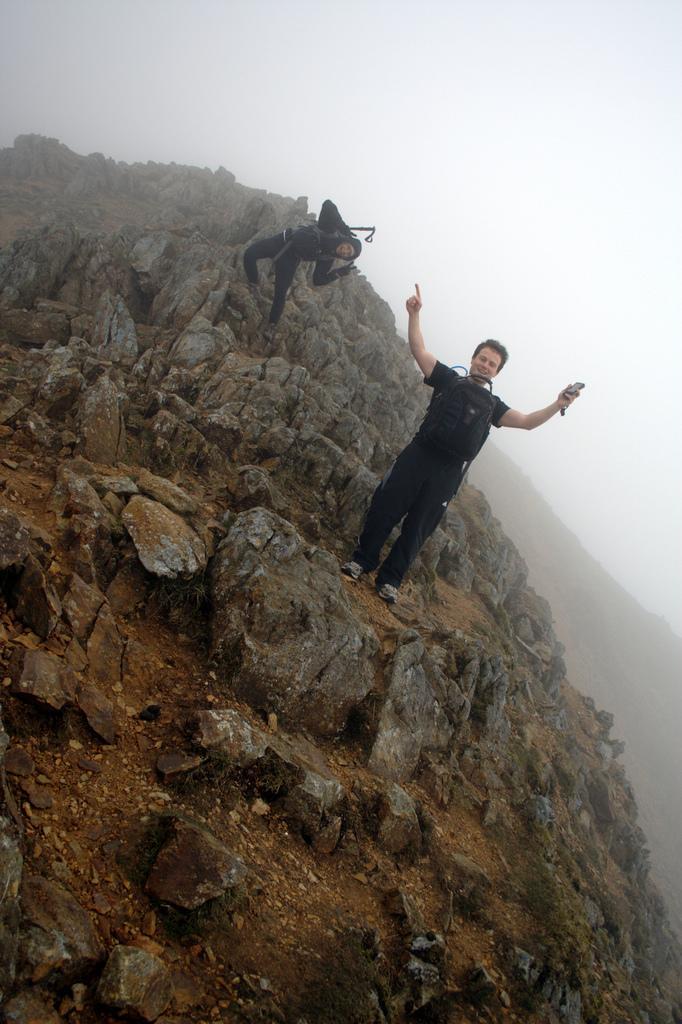Describe this image in one or two sentences. In the image there are two men in black dress standing on hill and above its sky. 